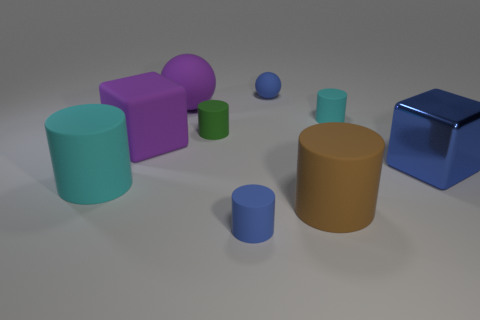What is the size of the rubber block that is the same color as the large ball?
Give a very brief answer. Large. Is the color of the tiny cylinder to the right of the big brown object the same as the big cylinder on the left side of the tiny green cylinder?
Offer a very short reply. Yes. What is the shape of the cyan matte object right of the tiny blue object that is in front of the blue object behind the big purple rubber sphere?
Make the answer very short. Cylinder. There is a rubber object that is both behind the tiny green matte cylinder and to the left of the small blue cylinder; what shape is it?
Your response must be concise. Sphere. There is a blue object to the right of the blue matte object that is behind the large matte sphere; how many tiny things are in front of it?
Your answer should be very brief. 1. What size is the blue object that is the same shape as the green rubber thing?
Your answer should be very brief. Small. Are the big cyan cylinder left of the purple matte cube and the large blue cube made of the same material?
Make the answer very short. No. There is another large rubber thing that is the same shape as the brown thing; what is its color?
Offer a terse response. Cyan. How many other objects are there of the same color as the tiny ball?
Ensure brevity in your answer.  2. There is a blue thing that is behind the metallic cube; does it have the same shape as the small blue matte thing that is in front of the small sphere?
Provide a short and direct response. No. 